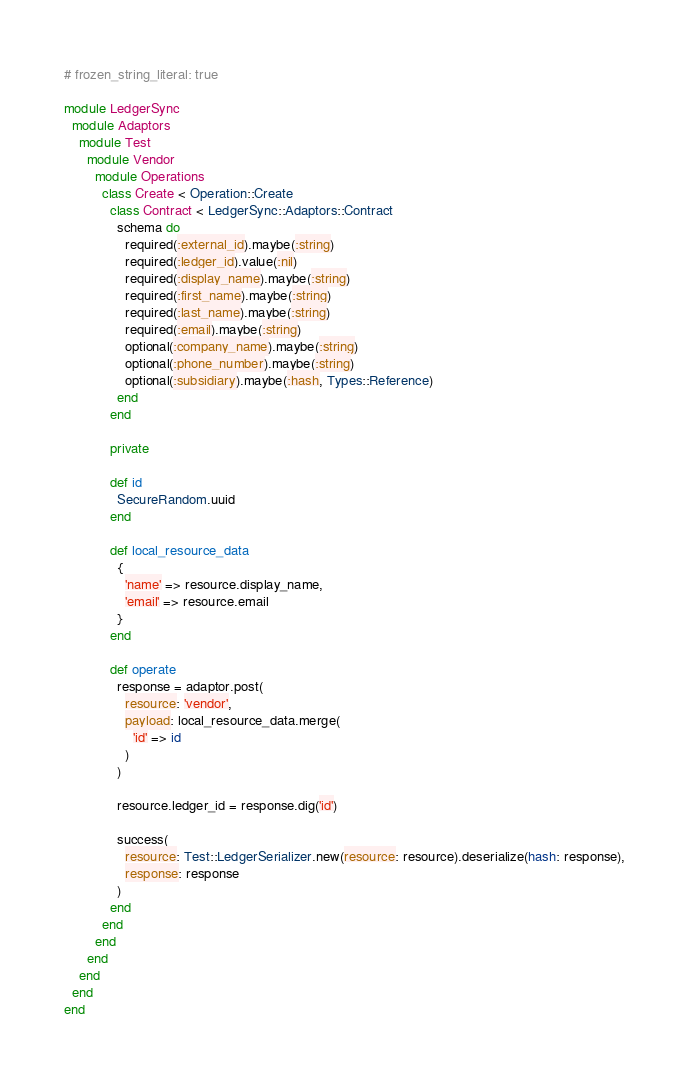<code> <loc_0><loc_0><loc_500><loc_500><_Ruby_># frozen_string_literal: true

module LedgerSync
  module Adaptors
    module Test
      module Vendor
        module Operations
          class Create < Operation::Create
            class Contract < LedgerSync::Adaptors::Contract
              schema do
                required(:external_id).maybe(:string)
                required(:ledger_id).value(:nil)
                required(:display_name).maybe(:string)
                required(:first_name).maybe(:string)
                required(:last_name).maybe(:string)
                required(:email).maybe(:string)
                optional(:company_name).maybe(:string)
                optional(:phone_number).maybe(:string)
                optional(:subsidiary).maybe(:hash, Types::Reference)
              end
            end

            private

            def id
              SecureRandom.uuid
            end

            def local_resource_data
              {
                'name' => resource.display_name,
                'email' => resource.email
              }
            end

            def operate
              response = adaptor.post(
                resource: 'vendor',
                payload: local_resource_data.merge(
                  'id' => id
                )
              )

              resource.ledger_id = response.dig('id')

              success(
                resource: Test::LedgerSerializer.new(resource: resource).deserialize(hash: response),
                response: response
              )
            end
          end
        end
      end
    end
  end
end
</code> 